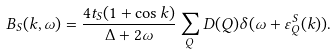<formula> <loc_0><loc_0><loc_500><loc_500>B _ { S } ( k , \omega ) = \frac { 4 t _ { S } ( 1 + \cos k ) } { \Delta + 2 \omega } \sum _ { Q } D ( Q ) \delta ( \omega + \varepsilon ^ { S } _ { Q } ( k ) ) .</formula> 